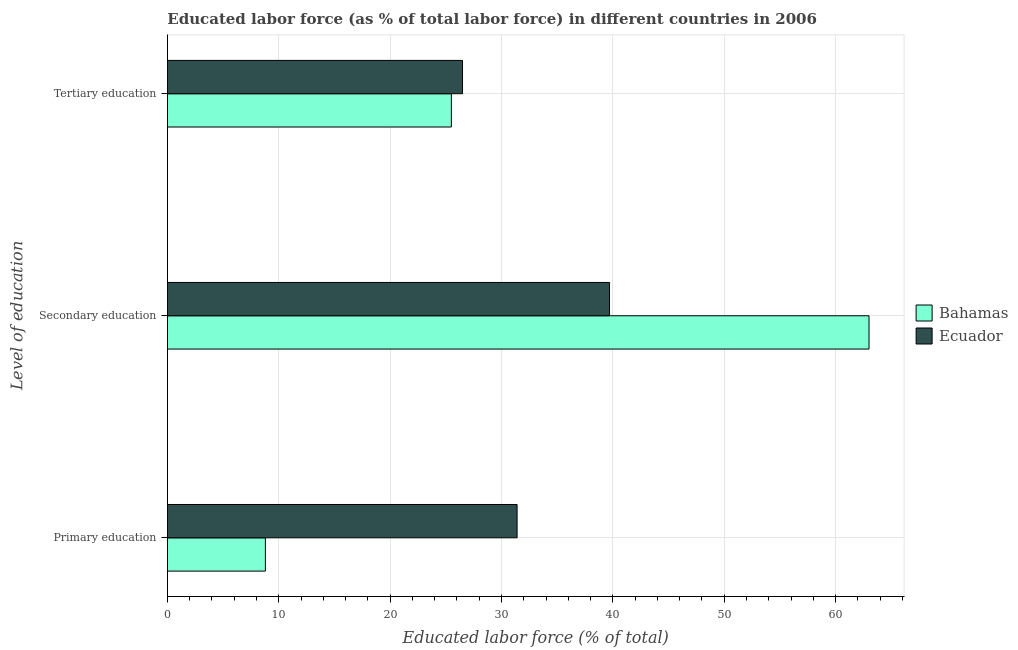How many different coloured bars are there?
Provide a succinct answer. 2. How many groups of bars are there?
Provide a succinct answer. 3. Are the number of bars per tick equal to the number of legend labels?
Your answer should be very brief. Yes. Are the number of bars on each tick of the Y-axis equal?
Offer a very short reply. Yes. How many bars are there on the 2nd tick from the top?
Offer a very short reply. 2. What is the label of the 1st group of bars from the top?
Your answer should be very brief. Tertiary education. Across all countries, what is the maximum percentage of labor force who received primary education?
Give a very brief answer. 31.4. Across all countries, what is the minimum percentage of labor force who received primary education?
Give a very brief answer. 8.8. In which country was the percentage of labor force who received tertiary education maximum?
Offer a terse response. Ecuador. In which country was the percentage of labor force who received primary education minimum?
Your answer should be compact. Bahamas. What is the total percentage of labor force who received tertiary education in the graph?
Provide a succinct answer. 52. What is the difference between the percentage of labor force who received tertiary education in Bahamas and that in Ecuador?
Offer a terse response. -1. What is the difference between the percentage of labor force who received primary education in Bahamas and the percentage of labor force who received secondary education in Ecuador?
Your answer should be compact. -30.9. What is the average percentage of labor force who received secondary education per country?
Your answer should be compact. 51.35. What is the difference between the percentage of labor force who received tertiary education and percentage of labor force who received primary education in Bahamas?
Offer a very short reply. 16.7. What is the ratio of the percentage of labor force who received tertiary education in Bahamas to that in Ecuador?
Make the answer very short. 0.96. Is the difference between the percentage of labor force who received primary education in Ecuador and Bahamas greater than the difference between the percentage of labor force who received secondary education in Ecuador and Bahamas?
Offer a terse response. Yes. What is the difference between the highest and the lowest percentage of labor force who received tertiary education?
Keep it short and to the point. 1. In how many countries, is the percentage of labor force who received secondary education greater than the average percentage of labor force who received secondary education taken over all countries?
Your response must be concise. 1. What does the 2nd bar from the top in Secondary education represents?
Your answer should be very brief. Bahamas. What does the 2nd bar from the bottom in Tertiary education represents?
Provide a succinct answer. Ecuador. How many bars are there?
Give a very brief answer. 6. What is the difference between two consecutive major ticks on the X-axis?
Give a very brief answer. 10. Does the graph contain grids?
Give a very brief answer. Yes. Where does the legend appear in the graph?
Your answer should be very brief. Center right. How are the legend labels stacked?
Offer a very short reply. Vertical. What is the title of the graph?
Your answer should be compact. Educated labor force (as % of total labor force) in different countries in 2006. What is the label or title of the X-axis?
Make the answer very short. Educated labor force (% of total). What is the label or title of the Y-axis?
Your answer should be compact. Level of education. What is the Educated labor force (% of total) in Bahamas in Primary education?
Make the answer very short. 8.8. What is the Educated labor force (% of total) of Ecuador in Primary education?
Your answer should be compact. 31.4. What is the Educated labor force (% of total) of Ecuador in Secondary education?
Your answer should be compact. 39.7. What is the Educated labor force (% of total) in Ecuador in Tertiary education?
Your answer should be compact. 26.5. Across all Level of education, what is the maximum Educated labor force (% of total) in Ecuador?
Offer a terse response. 39.7. Across all Level of education, what is the minimum Educated labor force (% of total) in Bahamas?
Provide a succinct answer. 8.8. Across all Level of education, what is the minimum Educated labor force (% of total) of Ecuador?
Ensure brevity in your answer.  26.5. What is the total Educated labor force (% of total) of Bahamas in the graph?
Keep it short and to the point. 97.3. What is the total Educated labor force (% of total) in Ecuador in the graph?
Provide a short and direct response. 97.6. What is the difference between the Educated labor force (% of total) in Bahamas in Primary education and that in Secondary education?
Provide a short and direct response. -54.2. What is the difference between the Educated labor force (% of total) in Ecuador in Primary education and that in Secondary education?
Your answer should be compact. -8.3. What is the difference between the Educated labor force (% of total) in Bahamas in Primary education and that in Tertiary education?
Your answer should be very brief. -16.7. What is the difference between the Educated labor force (% of total) in Ecuador in Primary education and that in Tertiary education?
Provide a short and direct response. 4.9. What is the difference between the Educated labor force (% of total) in Bahamas in Secondary education and that in Tertiary education?
Offer a terse response. 37.5. What is the difference between the Educated labor force (% of total) of Ecuador in Secondary education and that in Tertiary education?
Offer a very short reply. 13.2. What is the difference between the Educated labor force (% of total) in Bahamas in Primary education and the Educated labor force (% of total) in Ecuador in Secondary education?
Your answer should be very brief. -30.9. What is the difference between the Educated labor force (% of total) of Bahamas in Primary education and the Educated labor force (% of total) of Ecuador in Tertiary education?
Make the answer very short. -17.7. What is the difference between the Educated labor force (% of total) in Bahamas in Secondary education and the Educated labor force (% of total) in Ecuador in Tertiary education?
Offer a very short reply. 36.5. What is the average Educated labor force (% of total) in Bahamas per Level of education?
Your answer should be very brief. 32.43. What is the average Educated labor force (% of total) in Ecuador per Level of education?
Provide a succinct answer. 32.53. What is the difference between the Educated labor force (% of total) of Bahamas and Educated labor force (% of total) of Ecuador in Primary education?
Your answer should be compact. -22.6. What is the difference between the Educated labor force (% of total) of Bahamas and Educated labor force (% of total) of Ecuador in Secondary education?
Your answer should be very brief. 23.3. What is the difference between the Educated labor force (% of total) in Bahamas and Educated labor force (% of total) in Ecuador in Tertiary education?
Your answer should be compact. -1. What is the ratio of the Educated labor force (% of total) in Bahamas in Primary education to that in Secondary education?
Your answer should be compact. 0.14. What is the ratio of the Educated labor force (% of total) in Ecuador in Primary education to that in Secondary education?
Give a very brief answer. 0.79. What is the ratio of the Educated labor force (% of total) of Bahamas in Primary education to that in Tertiary education?
Offer a terse response. 0.35. What is the ratio of the Educated labor force (% of total) of Ecuador in Primary education to that in Tertiary education?
Keep it short and to the point. 1.18. What is the ratio of the Educated labor force (% of total) of Bahamas in Secondary education to that in Tertiary education?
Keep it short and to the point. 2.47. What is the ratio of the Educated labor force (% of total) in Ecuador in Secondary education to that in Tertiary education?
Make the answer very short. 1.5. What is the difference between the highest and the second highest Educated labor force (% of total) in Bahamas?
Offer a very short reply. 37.5. What is the difference between the highest and the second highest Educated labor force (% of total) in Ecuador?
Your answer should be compact. 8.3. What is the difference between the highest and the lowest Educated labor force (% of total) in Bahamas?
Keep it short and to the point. 54.2. What is the difference between the highest and the lowest Educated labor force (% of total) of Ecuador?
Make the answer very short. 13.2. 